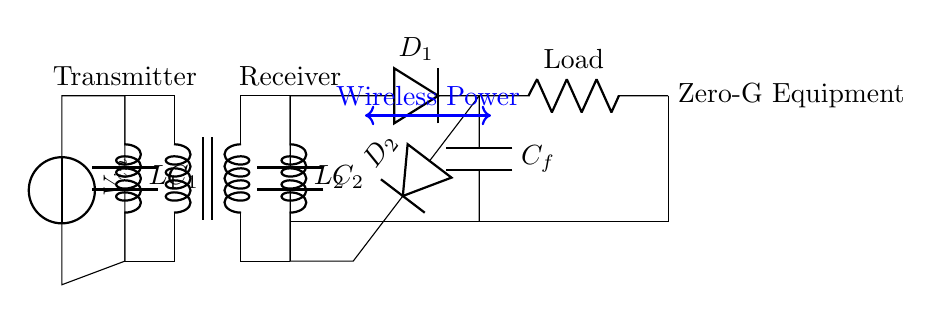What are the main components used in this circuit? The circuit consists of a transformer, inductors, capacitors, diodes, and a load. Each component is essential for wireless power transfer and load functionality.
Answer: transformer, inductors, capacitors, diodes, load What is the purpose of the transformer in this circuit? The transformer facilitates wireless power transfer by generating an alternating magnetic field, which induces an electric current in the secondary coil to charge the connected load.
Answer: wireless power transfer What are the values of the inductors in the circuit? The inductors are labeled as L1 and L2, but specific values aren't provided. Generally, these are used for inductive coupling in wireless circuits.
Answer: L1 and L2 Which components are used for rectification in the receiver part of the circuit? Diodes D1 and D2 are used for rectification in the receiver section; they convert alternating current from the transformer to direct current for the load.
Answer: D1 and D2 What is the role of capacitor C_f in this configuration? Capacitor C_f acts as a filter to smooth out the rectified current, improving the stability and performance of the power supply to the load.
Answer: smoothing the rectified current How is the load connected in this circuit? The load is connected in parallel with the rectified voltage from D1 and D2, allowing it to receive power once the joint current flows from the receiver circuit.
Answer: parallel connection to D1 and D2 